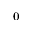Convert formula to latex. <formula><loc_0><loc_0><loc_500><loc_500>_ { 0 }</formula> 